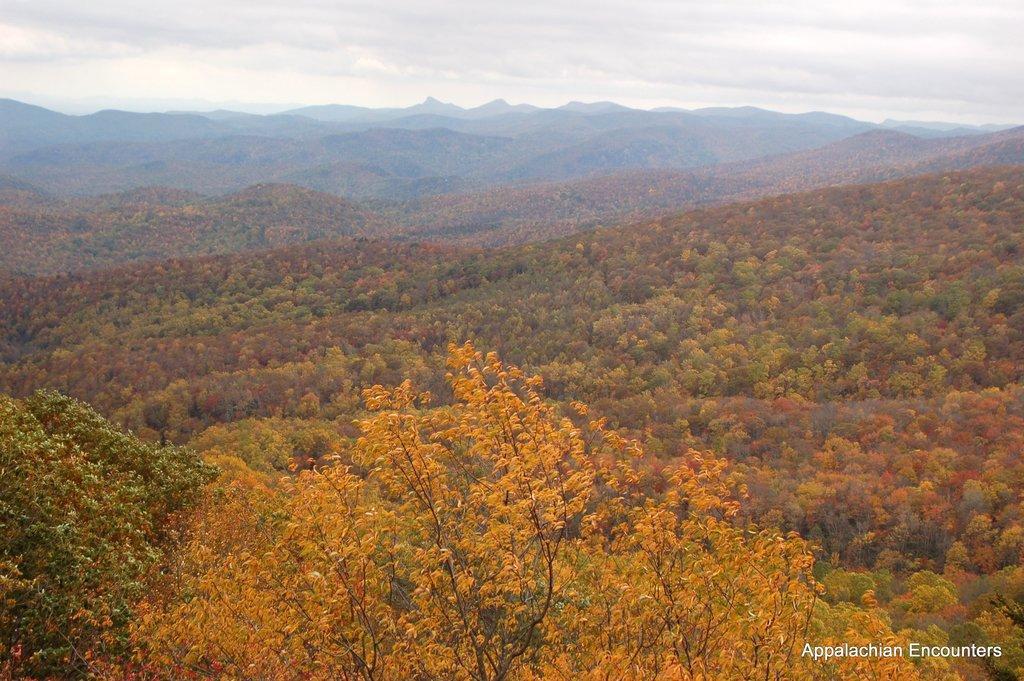Can you describe this image briefly? In this image we can see many hills. There are many trees in the image. There is a cloudy sky in the image. 